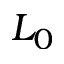<formula> <loc_0><loc_0><loc_500><loc_500>L _ { 0 }</formula> 